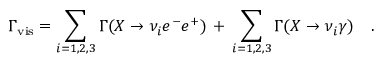Convert formula to latex. <formula><loc_0><loc_0><loc_500><loc_500>\Gamma _ { v i s } = \sum _ { i = 1 , 2 , 3 } \Gamma ( X \rightarrow \nu _ { i } e ^ { - } e ^ { + } ) \, + \, \sum _ { i = 1 , 2 , 3 } \Gamma ( X \rightarrow \nu _ { i } \gamma ) \quad .</formula> 